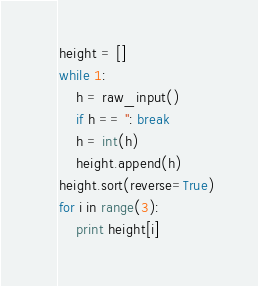Convert code to text. <code><loc_0><loc_0><loc_500><loc_500><_Python_>height = []
while 1:
    h = raw_input()
    if h == '': break
    h = int(h)
    height.append(h)
height.sort(reverse=True)
for i in range(3):
    print height[i]</code> 